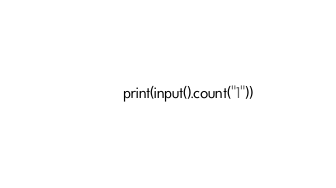Convert code to text. <code><loc_0><loc_0><loc_500><loc_500><_Python_>print(input().count("1"))</code> 